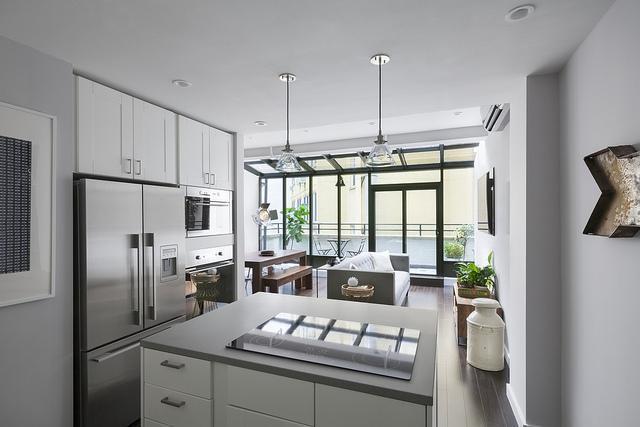How many pendant lights are hanging from the ceiling?
Give a very brief answer. 2. How many ovens are visible?
Give a very brief answer. 2. How many microwaves can you see?
Give a very brief answer. 1. How many people are walking in this picture?
Give a very brief answer. 0. 